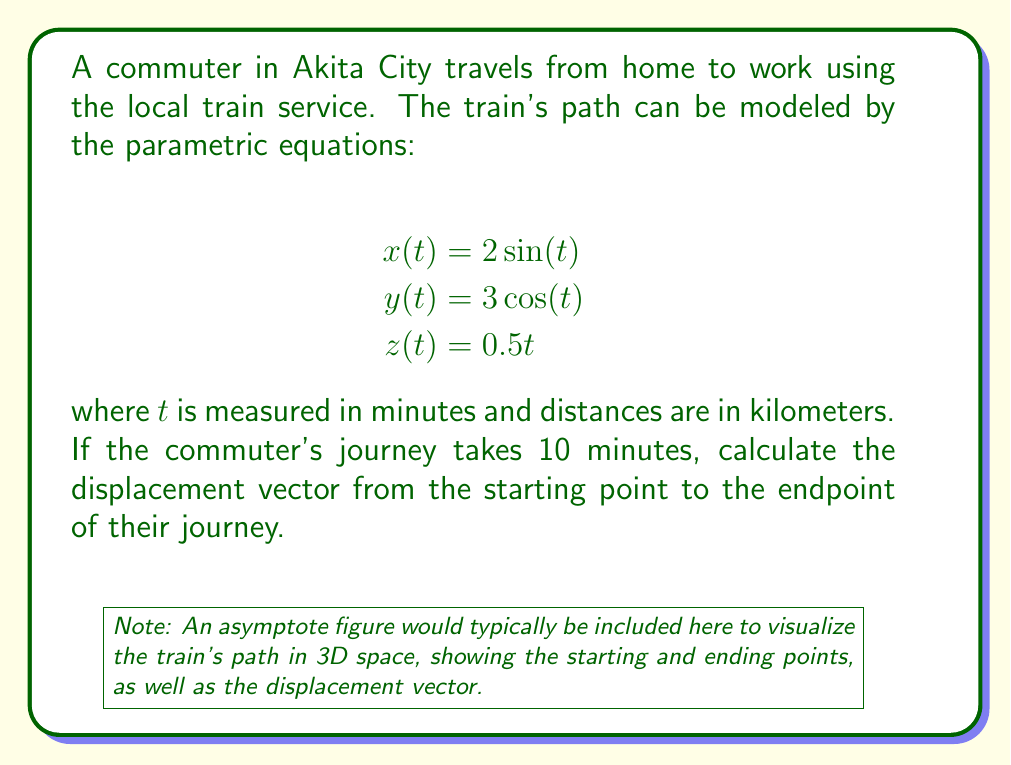Help me with this question. Let's solve this step-by-step:

1) To find the displacement vector, we need to calculate the difference between the endpoint and the starting point.

2) Starting point (at t = 0):
   $$x(0) = 2\sin(0) = 0$$
   $$y(0) = 3\cos(0) = 3$$
   $$z(0) = 0.5(0) = 0$$
   So, the starting point is $(0, 3, 0)$.

3) Endpoint (at t = 10):
   $$x(10) = 2\sin(10) \approx 1.682$$
   $$y(10) = 3\cos(10) \approx -1.403$$
   $$z(10) = 0.5(10) = 5$$
   So, the endpoint is approximately $(1.682, -1.403, 5)$.

4) The displacement vector is the difference between these points:
   $$\vec{d} = (1.682 - 0, -1.403 - 3, 5 - 0)$$
   $$\vec{d} = (1.682, -4.403, 5)$$

5) This vector represents the straight-line displacement from the starting point to the endpoint of the commuter's journey.
Answer: $(1.682, -4.403, 5)$ km 